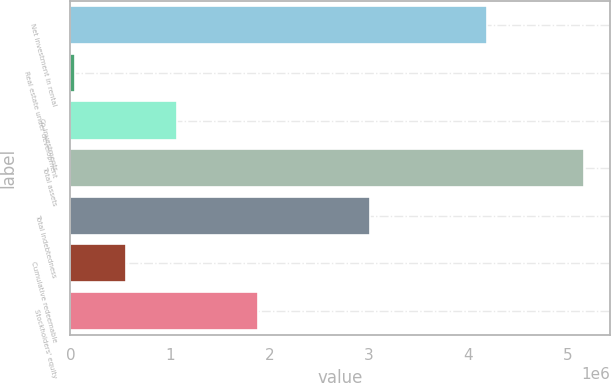Convert chart. <chart><loc_0><loc_0><loc_500><loc_500><bar_chart><fcel>Net investment in rental<fcel>Real estate under development<fcel>Co-investments<fcel>Total assets<fcel>Total indebtedness<fcel>Cumulative redeemable<fcel>Stockholders' equity<nl><fcel>4.18887e+06<fcel>50430<fcel>1.07281e+06<fcel>5.16232e+06<fcel>3.009e+06<fcel>561619<fcel>1.88462e+06<nl></chart> 